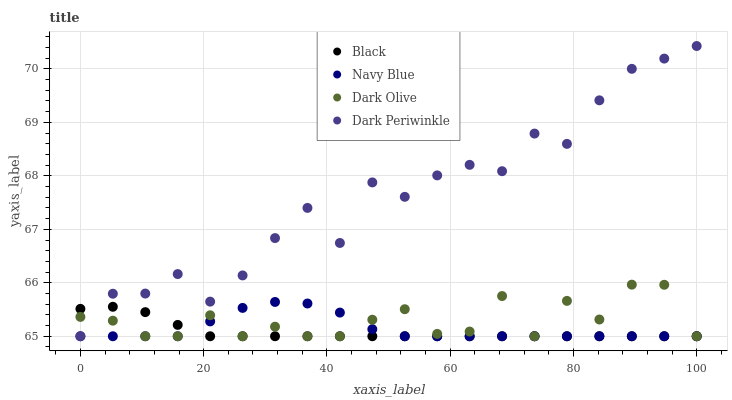Does Black have the minimum area under the curve?
Answer yes or no. Yes. Does Dark Periwinkle have the maximum area under the curve?
Answer yes or no. Yes. Does Dark Olive have the minimum area under the curve?
Answer yes or no. No. Does Dark Olive have the maximum area under the curve?
Answer yes or no. No. Is Black the smoothest?
Answer yes or no. Yes. Is Dark Periwinkle the roughest?
Answer yes or no. Yes. Is Dark Olive the smoothest?
Answer yes or no. No. Is Dark Olive the roughest?
Answer yes or no. No. Does Navy Blue have the lowest value?
Answer yes or no. Yes. Does Dark Periwinkle have the highest value?
Answer yes or no. Yes. Does Dark Olive have the highest value?
Answer yes or no. No. Does Navy Blue intersect Black?
Answer yes or no. Yes. Is Navy Blue less than Black?
Answer yes or no. No. Is Navy Blue greater than Black?
Answer yes or no. No. 